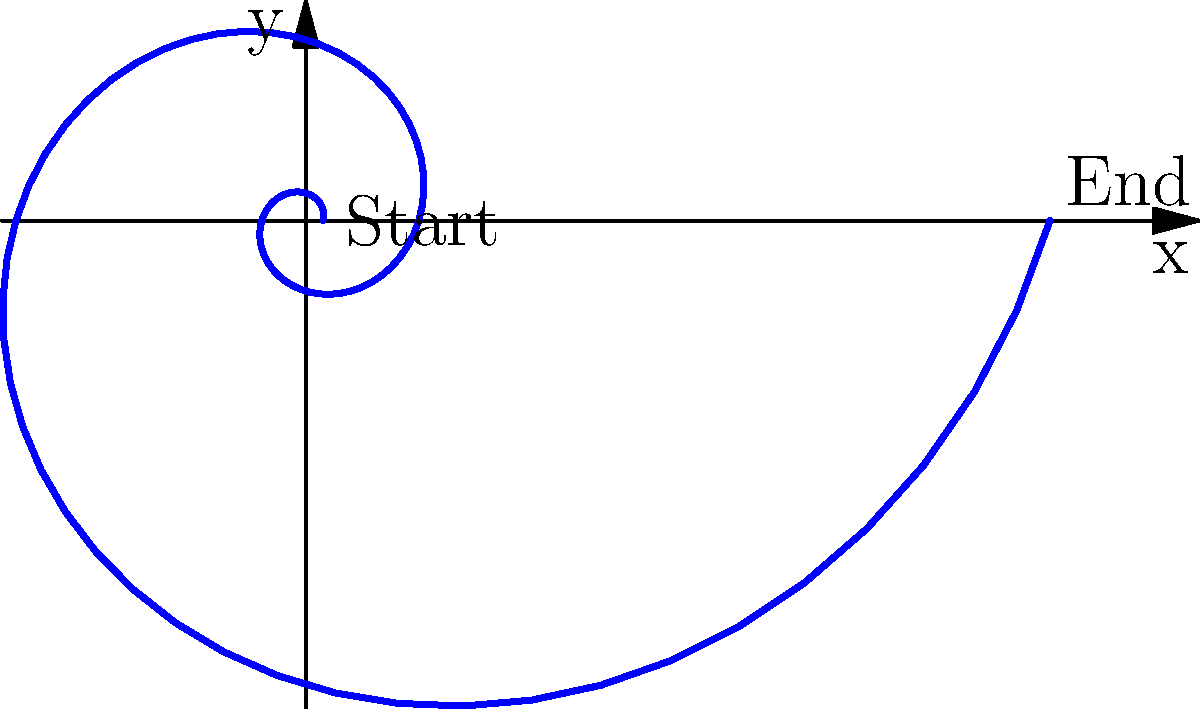In your garden, you've found a beautiful spiral seashell. The pattern of its growth can be described using a polar equation $r = 0.1e^{0.3\theta}$, where $r$ is the distance from the center and $\theta$ is the angle. As the shell grows, which direction does it spiral? Let's think about this step-by-step:

1. In a polar equation, $r$ represents the distance from the center, and $\theta$ represents the angle.

2. In this equation, $r = 0.1e^{0.3\theta}$, we can see that as $\theta$ increases, $r$ also increases because of the exponential function.

3. When $\theta = 0$, $r = 0.1$, which is the starting point of the spiral.

4. As $\theta$ increases (we move counterclockwise), $r$ gets larger, meaning the spiral moves further from the center.

5. This creates a spiral that moves outward as it rotates counterclockwise.

6. In the diagram, we can clearly see that the spiral starts near the center (marked "Start") and moves outward in a counterclockwise direction, ending at the point marked "End".

Therefore, the seashell spirals outward in a counterclockwise direction as it grows.
Answer: Counterclockwise 